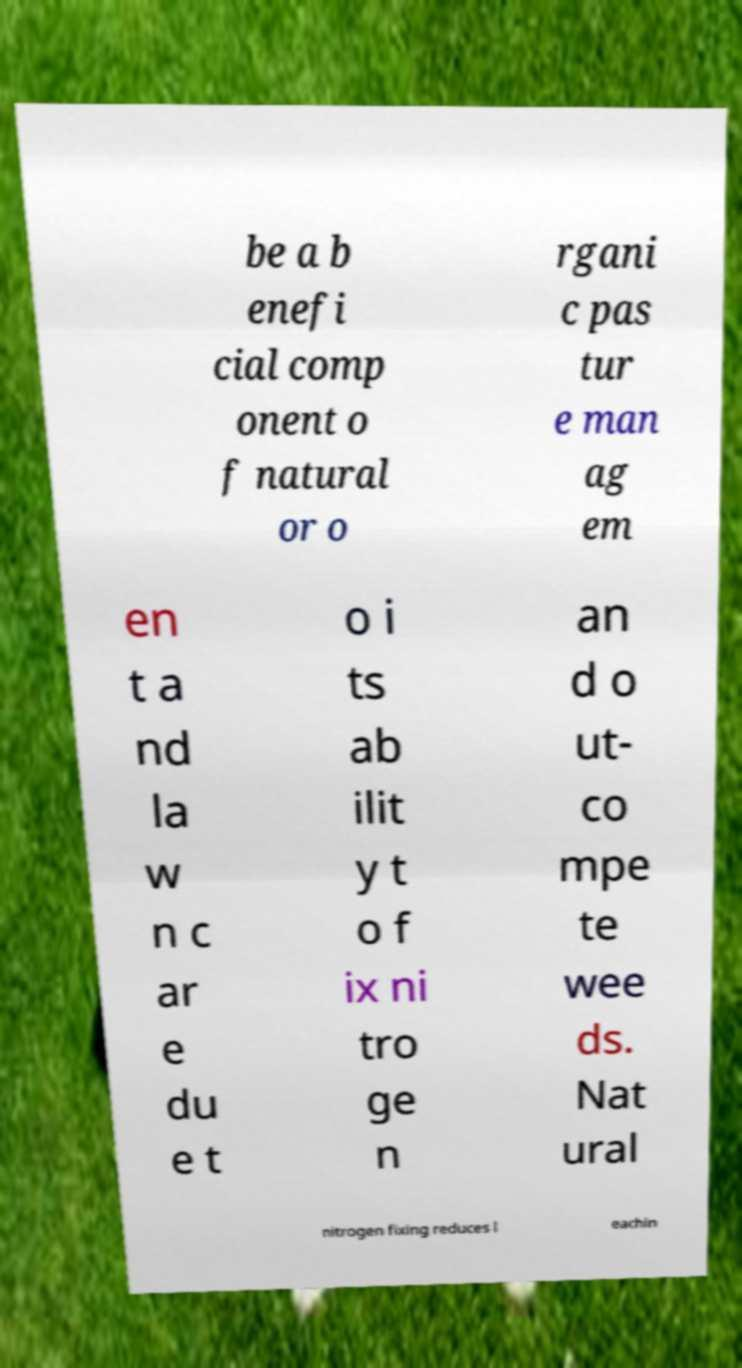Can you read and provide the text displayed in the image?This photo seems to have some interesting text. Can you extract and type it out for me? be a b enefi cial comp onent o f natural or o rgani c pas tur e man ag em en t a nd la w n c ar e du e t o i ts ab ilit y t o f ix ni tro ge n an d o ut- co mpe te wee ds. Nat ural nitrogen fixing reduces l eachin 